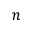<formula> <loc_0><loc_0><loc_500><loc_500>n</formula> 